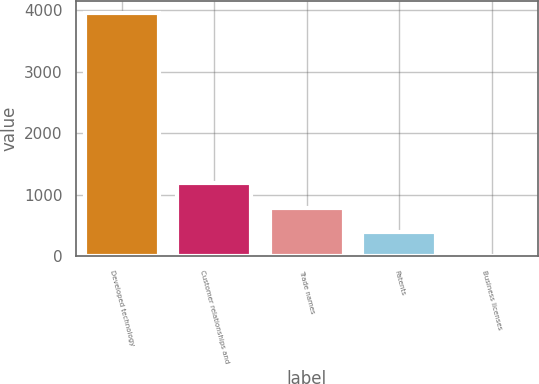Convert chart to OTSL. <chart><loc_0><loc_0><loc_500><loc_500><bar_chart><fcel>Developed technology<fcel>Customer relationships and<fcel>Trade names<fcel>Patents<fcel>Business licenses<nl><fcel>3951.1<fcel>1187.15<fcel>792.3<fcel>397.45<fcel>2.6<nl></chart> 